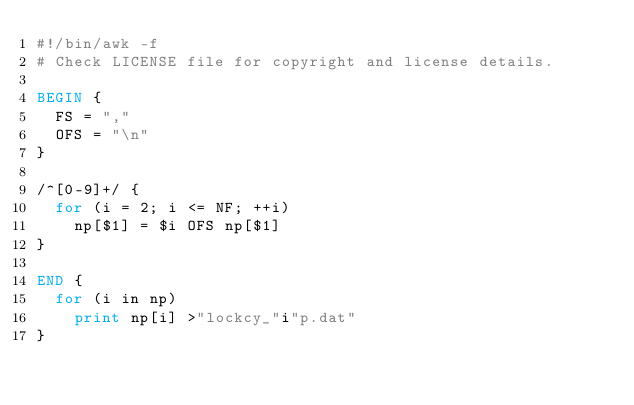<code> <loc_0><loc_0><loc_500><loc_500><_Awk_>#!/bin/awk -f
# Check LICENSE file for copyright and license details.

BEGIN {
	FS = ","
	OFS = "\n"
}

/^[0-9]+/ {
	for (i = 2; i <= NF; ++i)
		np[$1] = $i OFS np[$1]
}

END {
	for (i in np)
		print np[i] >"lockcy_"i"p.dat"
}
</code> 